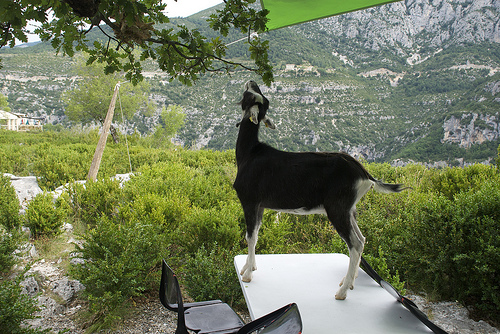<image>
Can you confirm if the coat is on the table? Yes. Looking at the image, I can see the coat is positioned on top of the table, with the table providing support. 